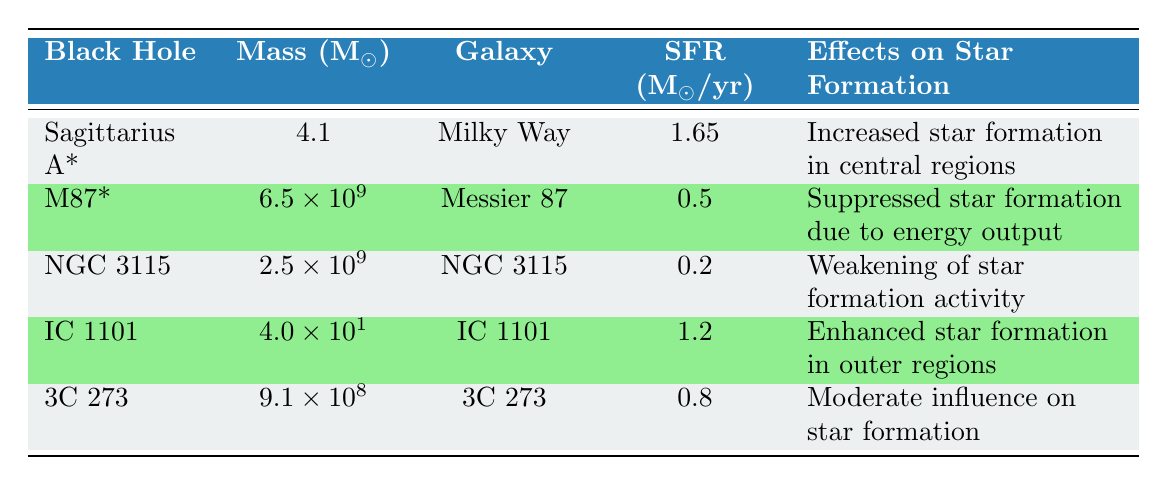What is the star formation rate in the Milky Way? The star formation rate for the Milky Way, as listed in the table, is 1.65 solar masses per year.
Answer: 1.65 Which black hole has the highest mass according to the table? The table shows that M87* has the highest mass at 6.5 billion solar masses.
Answer: M87* How many black holes have a star formation rate greater than 1 solar mass per year? The table lists Sagittarius A* and IC 1101 with star formation rates of 1.65 and 1.2 solar masses per year respectively. Summing the counts gives us two black holes.
Answer: 2 Is it true that the effects of M87* on star formation are suppression due to energy output? Yes, according to the table, the effects of M87* on star formation are indeed suppressed due to its energy output.
Answer: Yes What is the average star formation rate of the black holes listed in the table? The star formation rates are 1.65, 0.5, 0.2, 1.2, and 0.8 solar masses per year. Summing these gives 4.35, and dividing by 5 (the number of black holes) gives an average of 0.87.
Answer: 0.87 What galaxy is closest to a black hole based on the distance metric in the table? Looking at the distance to black holes, both Sagittarius A* and NGC 3115 have a distance of 0 kpc, indicating they are located right at the center of their respective galaxies.
Answer: Milky Way and NGC 3115 Which black hole is associated with the most weakening of star formation activity? The table indicates that NGC 3115 is associated with a "weakening of star formation activity," meaning it has the most significant negative impact on star formation.
Answer: NGC 3115 How does the star formation rate in Messier 87 compare to that of IC 1101? The star formation rate in Messier 87 is 0.5 solar masses per year while IC 1101 has a rate of 1.2 solar masses per year. Therefore, IC 1101 has a higher star formation rate than Messier 87.
Answer: IC 1101 has a higher star formation rate than Messier 87 